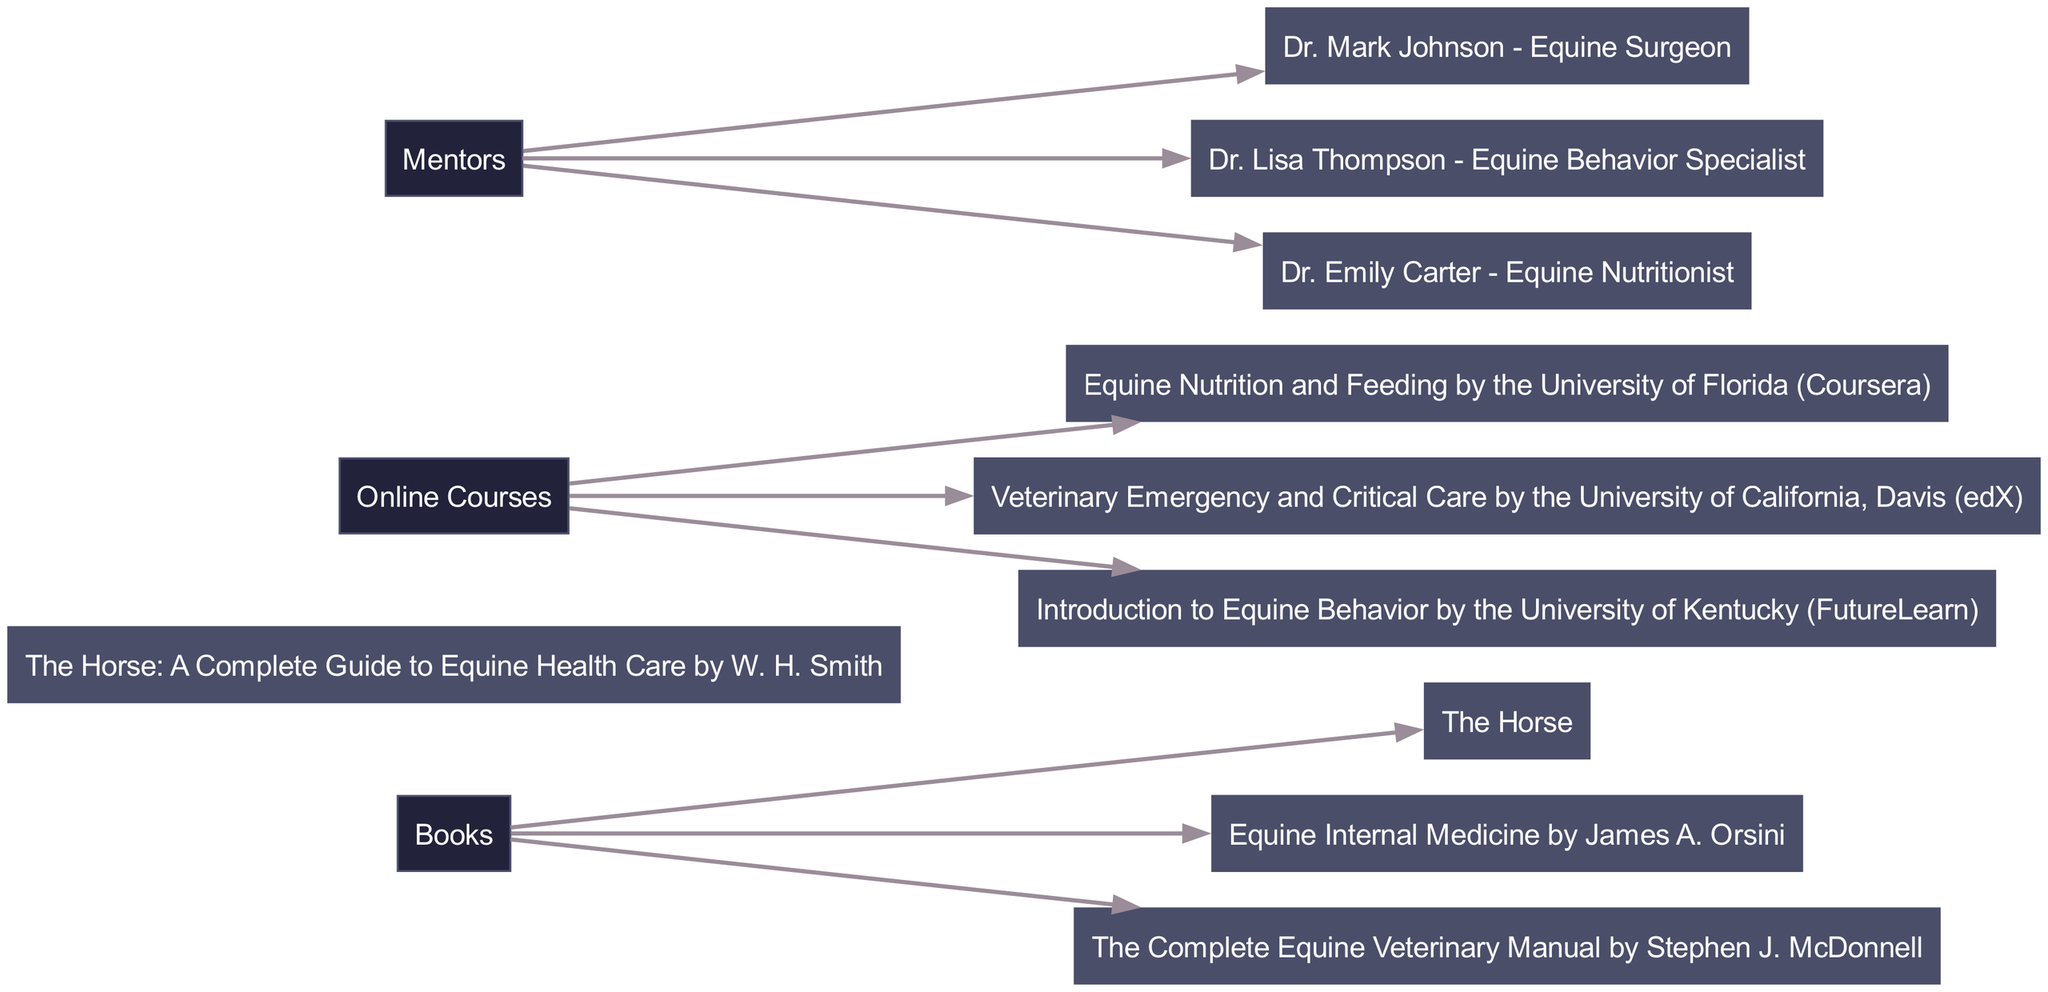What are the three main sources of information in equine medicine? The diagram shows three main sources which are Books, Online Courses, and Mentors. These sources are listed as the primary categories in the diagram's structure.
Answer: Books, Online Courses, Mentors How many books are listed in the diagram? The diagram indicates that there are three books mentioned under the Books source. This can be counted by looking at the items listed.
Answer: 3 Which online course focuses on equine nutrition? The course titled "Equine Nutrition and Feeding by the University of Florida (Coursera)" is specifically related to equine nutrition. This is found under the Online Courses node.
Answer: Equine Nutrition and Feeding by the University of Florida (Coursera) Who is the equine behavior specialist mentioned as a mentor? The mentor identified as "Dr. Lisa Thompson - Equine Behavior Specialist" is the one focusing on equine behavior. This name is connected under the Mentors node.
Answer: Dr. Lisa Thompson - Equine Behavior Specialist Is there an edge connecting the Books source to "The Complete Equine Veterinary Manual"? Yes, there is a direct edge connecting the Books source to "The Complete Equine Veterinary Manual," indicating that this book falls under the source of books in equine medicine.
Answer: Yes Which source has the highest number of items listed? Since there is no numerical representation beside the sources, a visual comparison of items under each source shows that all sources have equal representation. Each source has three items listed, leading to the conclusion that they are all tied.
Answer: Equal What type of information does Dr. Mark Johnson provide as a mentor? Dr. Mark Johnson, who is specifically mentioned as an Equine Surgeon, contributes expertise in surgical matters related to equine medicine. This categorization can be found under the Mentors node.
Answer: Equine Surgeon Are there any duplicates in the sources mentioned in the diagram? The diagram showcases distinct items under each source without any repeated entries. A careful check against each of the items under Books, Online Courses, and Mentors confirms that there are no duplicates.
Answer: No How many edges are represented in total between the sources and their respective items? The diagram includes a total of nine edges: three from Books to three books, three from Online Courses to three courses, and three from Mentors to three mentors, leading to the summation of 9 edges.
Answer: 9 